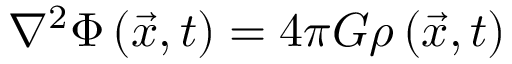<formula> <loc_0><loc_0><loc_500><loc_500>\nabla ^ { 2 } \Phi \left ( { \vec { x } } , t \right ) = 4 \pi G \rho \left ( { \vec { x } } , t \right )</formula> 